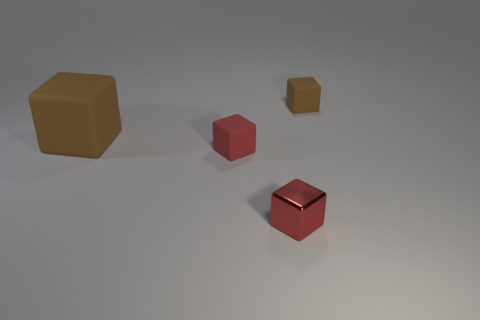Add 3 big rubber cubes. How many objects exist? 7 Add 3 brown rubber blocks. How many brown rubber blocks exist? 5 Subtract 0 purple cylinders. How many objects are left? 4 Subtract all brown balls. Subtract all small red metal cubes. How many objects are left? 3 Add 2 big rubber objects. How many big rubber objects are left? 3 